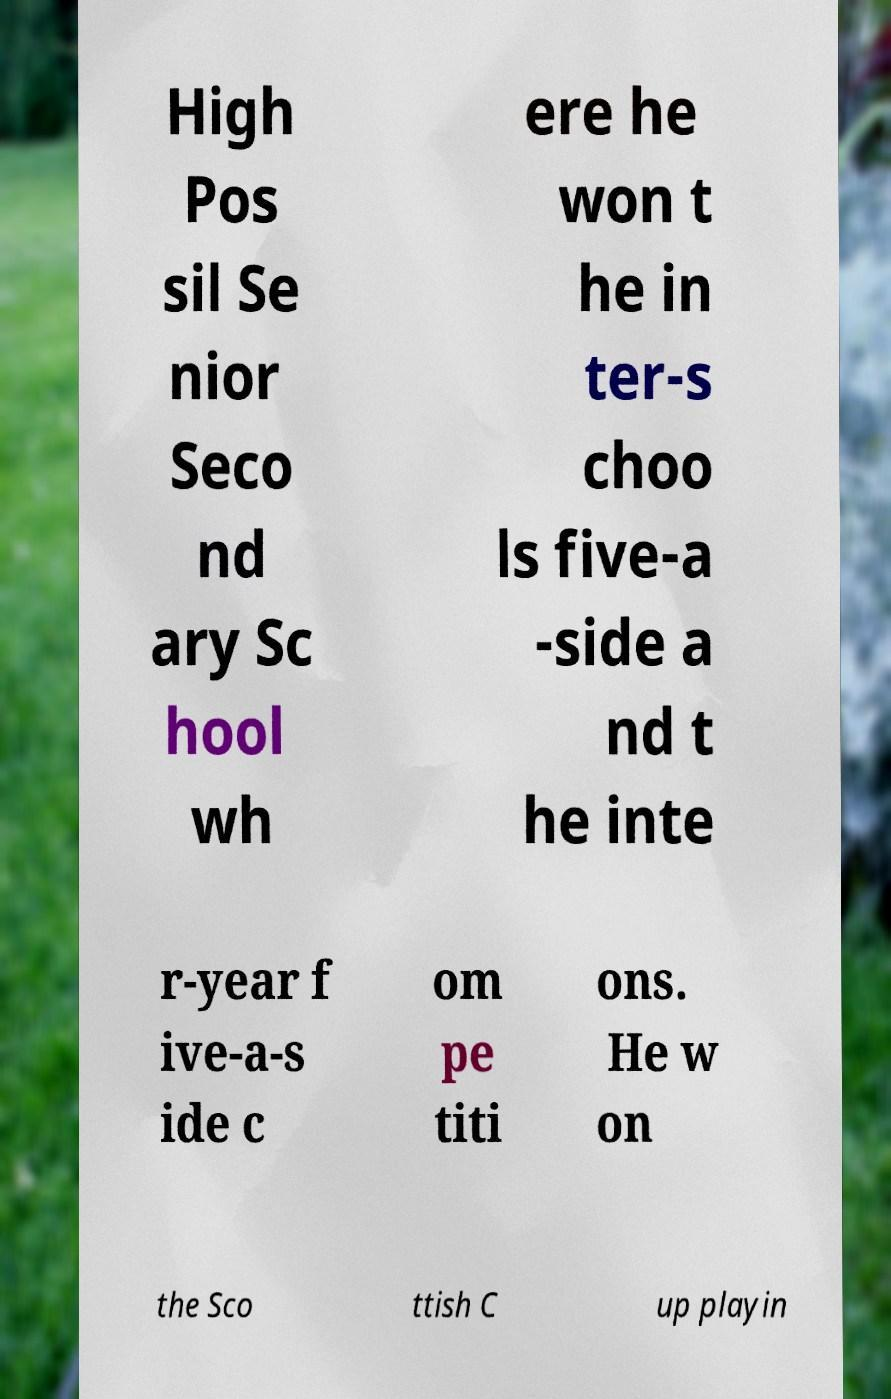Can you accurately transcribe the text from the provided image for me? High Pos sil Se nior Seco nd ary Sc hool wh ere he won t he in ter-s choo ls five-a -side a nd t he inte r-year f ive-a-s ide c om pe titi ons. He w on the Sco ttish C up playin 